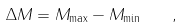Convert formula to latex. <formula><loc_0><loc_0><loc_500><loc_500>\Delta M = M _ { \max } - M _ { \min } \quad ,</formula> 